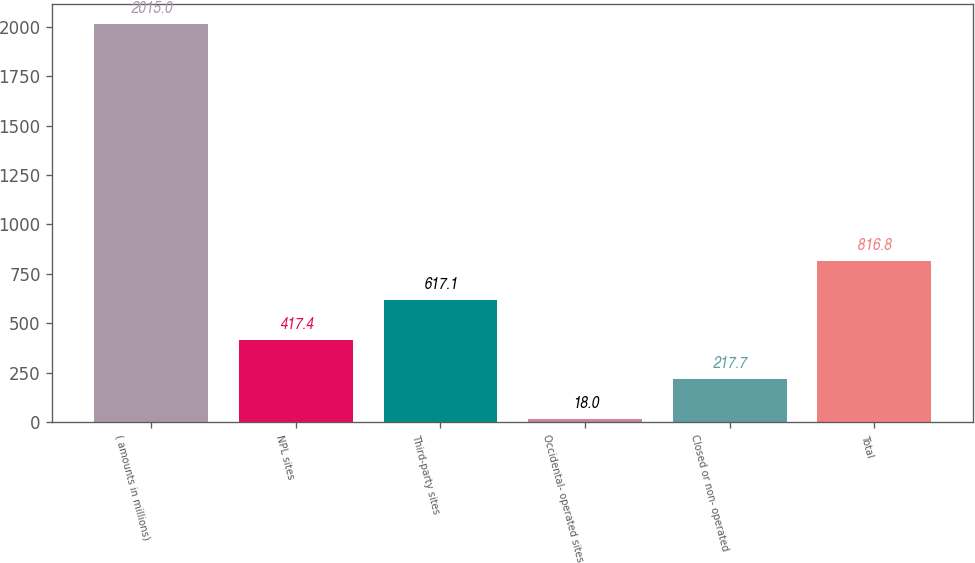Convert chart to OTSL. <chart><loc_0><loc_0><loc_500><loc_500><bar_chart><fcel>( amounts in millions)<fcel>NPL sites<fcel>Third-party sites<fcel>Occidental- operated sites<fcel>Closed or non- operated<fcel>Total<nl><fcel>2015<fcel>417.4<fcel>617.1<fcel>18<fcel>217.7<fcel>816.8<nl></chart> 